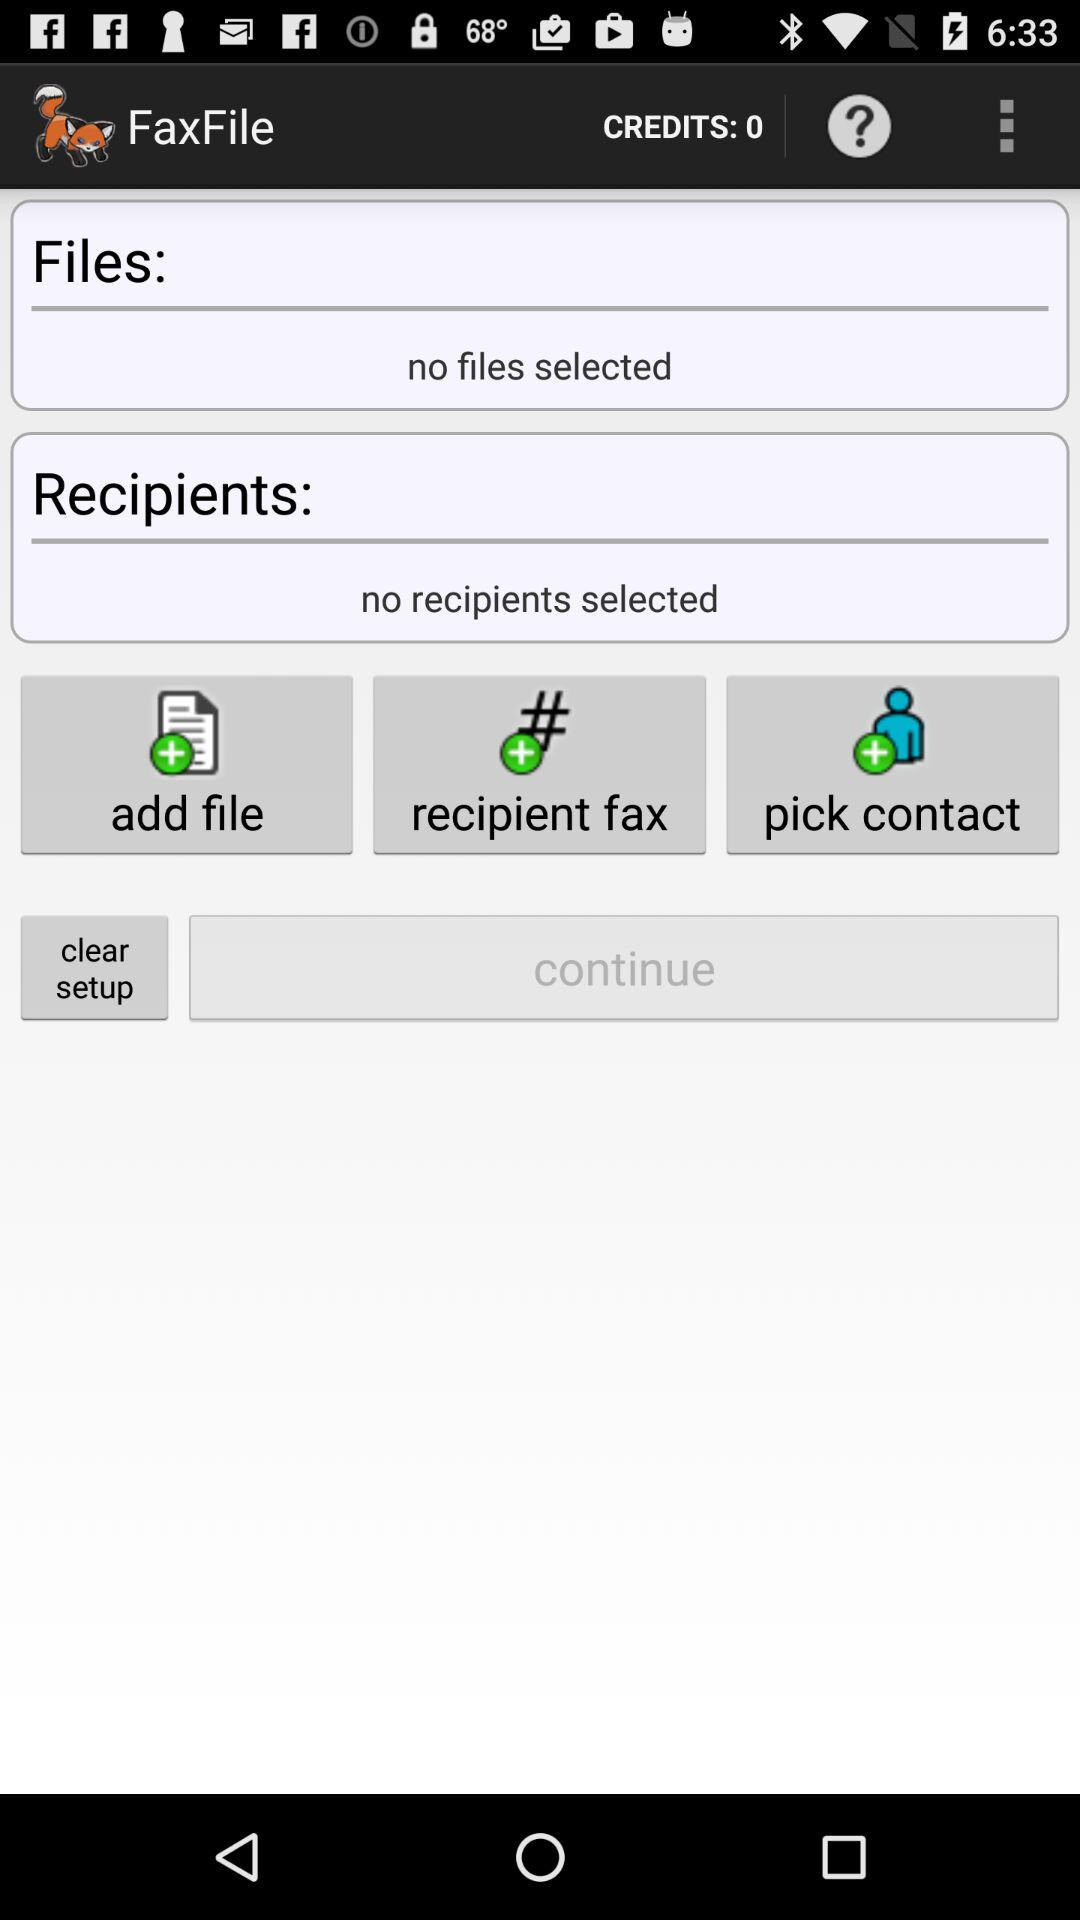Are there any files selected? There are no files selected. 